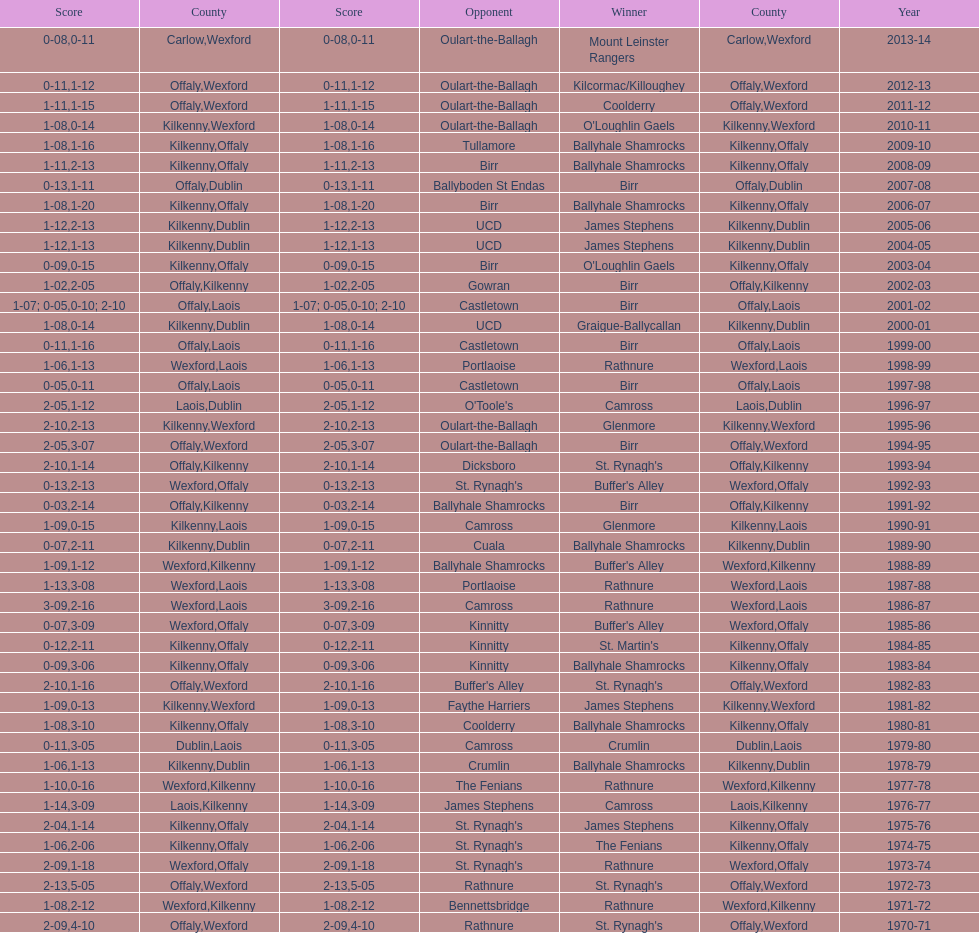Could you parse the entire table? {'header': ['Score', 'County', 'Score', 'Opponent', 'Winner', 'County', 'Year'], 'rows': [['0-08', 'Carlow', '0-11', 'Oulart-the-Ballagh', 'Mount Leinster Rangers', 'Wexford', '2013-14'], ['0-11', 'Offaly', '1-12', 'Oulart-the-Ballagh', 'Kilcormac/Killoughey', 'Wexford', '2012-13'], ['1-11', 'Offaly', '1-15', 'Oulart-the-Ballagh', 'Coolderry', 'Wexford', '2011-12'], ['1-08', 'Kilkenny', '0-14', 'Oulart-the-Ballagh', "O'Loughlin Gaels", 'Wexford', '2010-11'], ['1-08', 'Kilkenny', '1-16', 'Tullamore', 'Ballyhale Shamrocks', 'Offaly', '2009-10'], ['1-11', 'Kilkenny', '2-13', 'Birr', 'Ballyhale Shamrocks', 'Offaly', '2008-09'], ['0-13', 'Offaly', '1-11', 'Ballyboden St Endas', 'Birr', 'Dublin', '2007-08'], ['1-08', 'Kilkenny', '1-20', 'Birr', 'Ballyhale Shamrocks', 'Offaly', '2006-07'], ['1-12', 'Kilkenny', '2-13', 'UCD', 'James Stephens', 'Dublin', '2005-06'], ['1-12', 'Kilkenny', '1-13', 'UCD', 'James Stephens', 'Dublin', '2004-05'], ['0-09', 'Kilkenny', '0-15', 'Birr', "O'Loughlin Gaels", 'Offaly', '2003-04'], ['1-02', 'Offaly', '2-05', 'Gowran', 'Birr', 'Kilkenny', '2002-03'], ['1-07; 0-05', 'Offaly', '0-10; 2-10', 'Castletown', 'Birr', 'Laois', '2001-02'], ['1-08', 'Kilkenny', '0-14', 'UCD', 'Graigue-Ballycallan', 'Dublin', '2000-01'], ['0-11', 'Offaly', '1-16', 'Castletown', 'Birr', 'Laois', '1999-00'], ['1-06', 'Wexford', '1-13', 'Portlaoise', 'Rathnure', 'Laois', '1998-99'], ['0-05', 'Offaly', '0-11', 'Castletown', 'Birr', 'Laois', '1997-98'], ['2-05', 'Laois', '1-12', "O'Toole's", 'Camross', 'Dublin', '1996-97'], ['2-10', 'Kilkenny', '2-13', 'Oulart-the-Ballagh', 'Glenmore', 'Wexford', '1995-96'], ['2-05', 'Offaly', '3-07', 'Oulart-the-Ballagh', 'Birr', 'Wexford', '1994-95'], ['2-10', 'Offaly', '1-14', 'Dicksboro', "St. Rynagh's", 'Kilkenny', '1993-94'], ['0-13', 'Wexford', '2-13', "St. Rynagh's", "Buffer's Alley", 'Offaly', '1992-93'], ['0-03', 'Offaly', '2-14', 'Ballyhale Shamrocks', 'Birr', 'Kilkenny', '1991-92'], ['1-09', 'Kilkenny', '0-15', 'Camross', 'Glenmore', 'Laois', '1990-91'], ['0-07', 'Kilkenny', '2-11', 'Cuala', 'Ballyhale Shamrocks', 'Dublin', '1989-90'], ['1-09', 'Wexford', '1-12', 'Ballyhale Shamrocks', "Buffer's Alley", 'Kilkenny', '1988-89'], ['1-13', 'Wexford', '3-08', 'Portlaoise', 'Rathnure', 'Laois', '1987-88'], ['3-09', 'Wexford', '2-16', 'Camross', 'Rathnure', 'Laois', '1986-87'], ['0-07', 'Wexford', '3-09', 'Kinnitty', "Buffer's Alley", 'Offaly', '1985-86'], ['0-12', 'Kilkenny', '2-11', 'Kinnitty', "St. Martin's", 'Offaly', '1984-85'], ['0-09', 'Kilkenny', '3-06', 'Kinnitty', 'Ballyhale Shamrocks', 'Offaly', '1983-84'], ['2-10', 'Offaly', '1-16', "Buffer's Alley", "St. Rynagh's", 'Wexford', '1982-83'], ['1-09', 'Kilkenny', '0-13', 'Faythe Harriers', 'James Stephens', 'Wexford', '1981-82'], ['1-08', 'Kilkenny', '3-10', 'Coolderry', 'Ballyhale Shamrocks', 'Offaly', '1980-81'], ['0-11', 'Dublin', '3-05', 'Camross', 'Crumlin', 'Laois', '1979-80'], ['1-06', 'Kilkenny', '1-13', 'Crumlin', 'Ballyhale Shamrocks', 'Dublin', '1978-79'], ['1-10', 'Wexford', '0-16', 'The Fenians', 'Rathnure', 'Kilkenny', '1977-78'], ['1-14', 'Laois', '3-09', 'James Stephens', 'Camross', 'Kilkenny', '1976-77'], ['2-04', 'Kilkenny', '1-14', "St. Rynagh's", 'James Stephens', 'Offaly', '1975-76'], ['1-06', 'Kilkenny', '2-06', "St. Rynagh's", 'The Fenians', 'Offaly', '1974-75'], ['2-09', 'Wexford', '1-18', "St. Rynagh's", 'Rathnure', 'Offaly', '1973-74'], ['2-13', 'Offaly', '5-05', 'Rathnure', "St. Rynagh's", 'Wexford', '1972-73'], ['1-08', 'Wexford', '2-12', 'Bennettsbridge', 'Rathnure', 'Kilkenny', '1971-72'], ['2-09', 'Offaly', '4-10', 'Rathnure', "St. Rynagh's", 'Wexford', '1970-71']]} Which team won the leinster senior club hurling championships previous to the last time birr won? Ballyhale Shamrocks. 